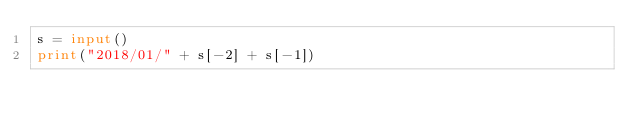<code> <loc_0><loc_0><loc_500><loc_500><_Python_>s = input()
print("2018/01/" + s[-2] + s[-1])</code> 